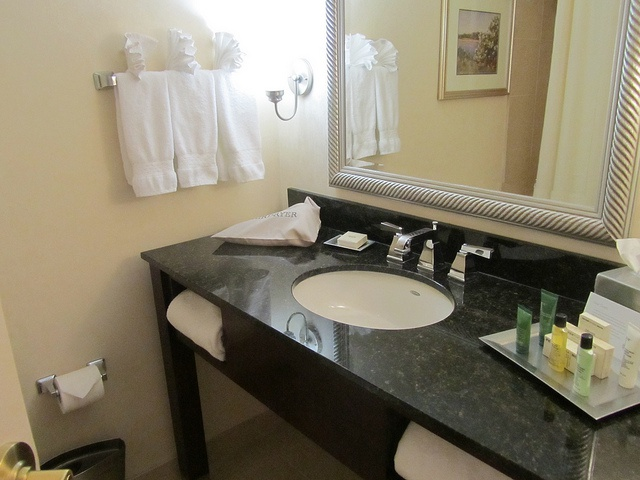Describe the objects in this image and their specific colors. I can see a sink in tan, black, and gray tones in this image. 